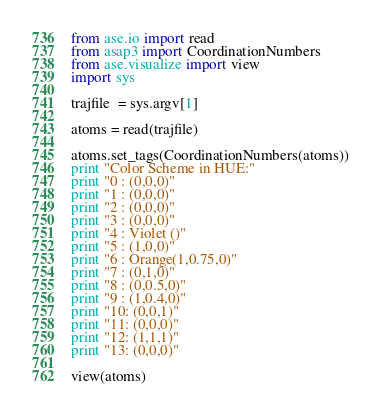<code> <loc_0><loc_0><loc_500><loc_500><_Python_>from ase.io import read
from asap3 import CoordinationNumbers
from ase.visualize import view
import sys

trajfile  = sys.argv[1]

atoms = read(trajfile)

atoms.set_tags(CoordinationNumbers(atoms))
print "Color Scheme in HUE:"
print "0 : (0,0,0)"
print "1 : (0,0,0)"
print "2 : (0,0,0)"
print "3 : (0,0,0)"
print "4 : Violet ()"
print "5 : (1,0,0)"
print "6 : Orange(1,0.75,0)"
print "7 : (0,1,0)"
print "8 : (0,0.5,0)"
print "9 : (1,0.4,0)"
print "10: (0,0,1)"
print "11: (0,0,0)"
print "12: (1,1,1)"
print "13: (0,0,0)"

view(atoms)
</code> 